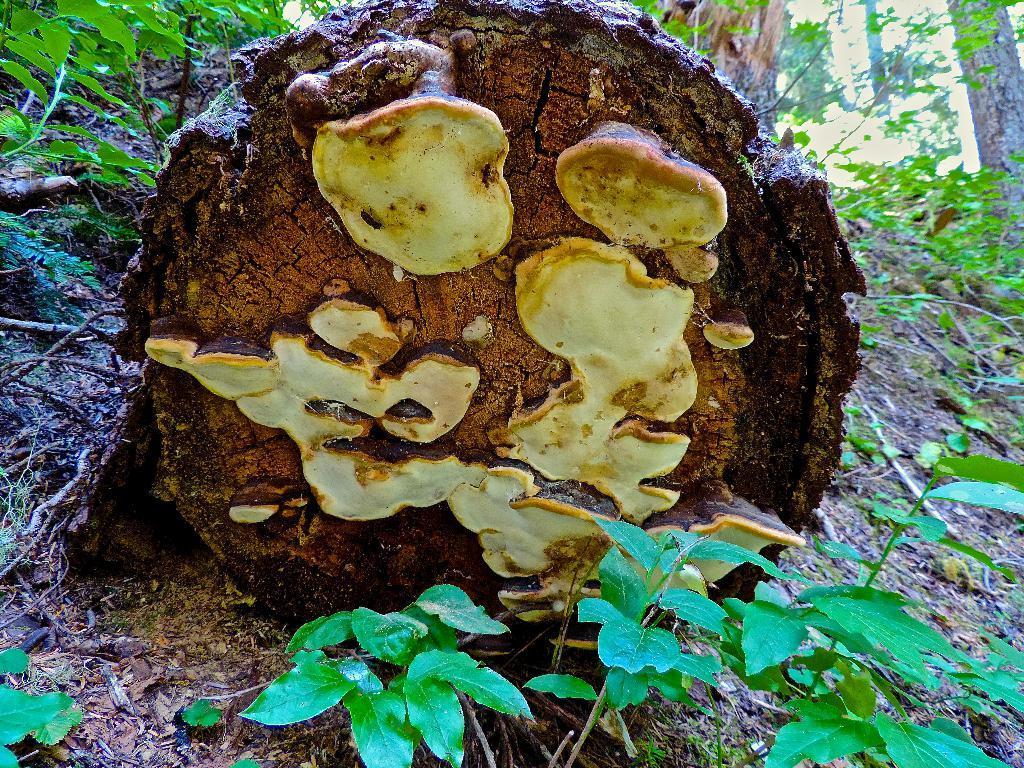How would you summarize this image in a sentence or two? This image consists of a bark of a bark of a tree. At the bottom, there are small plants. It looks like it is clicked in a forest. 